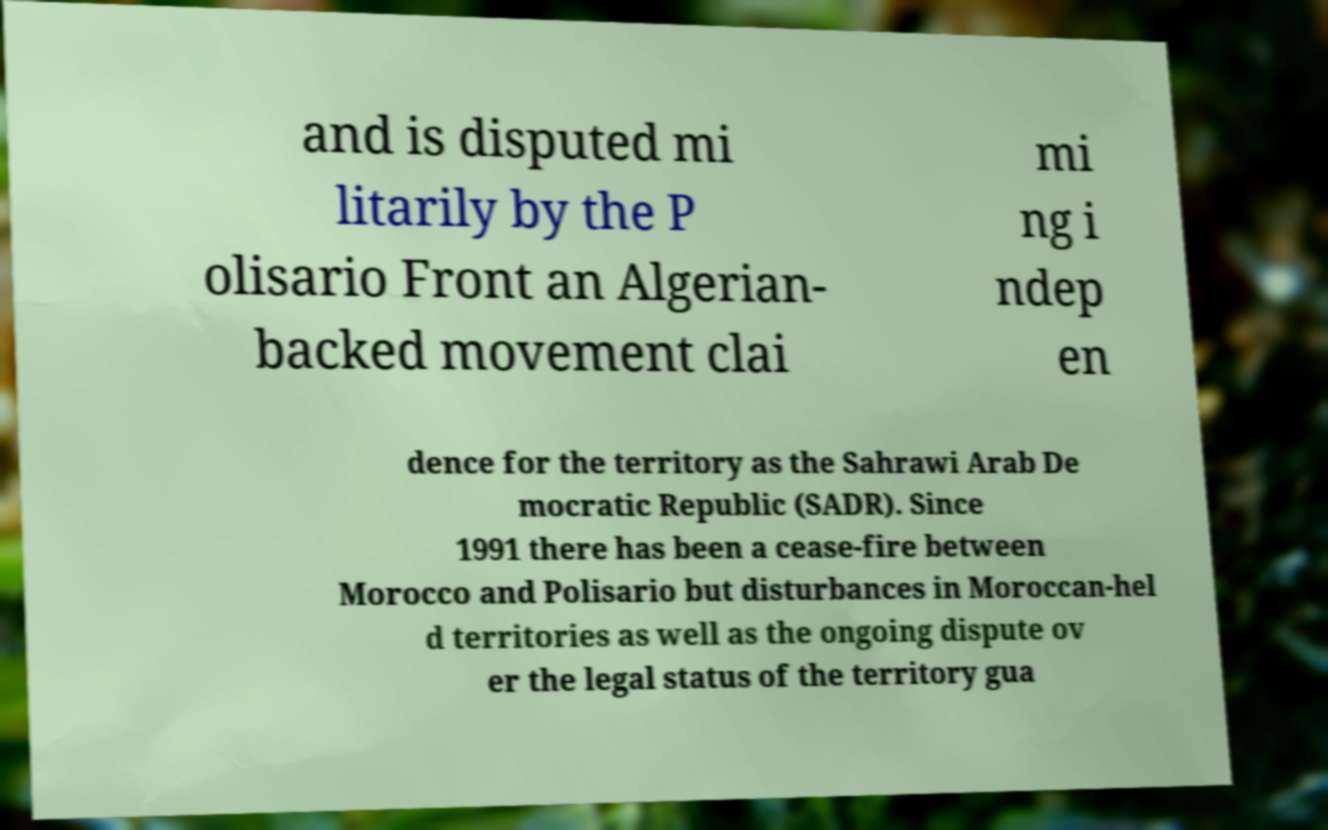Can you accurately transcribe the text from the provided image for me? and is disputed mi litarily by the P olisario Front an Algerian- backed movement clai mi ng i ndep en dence for the territory as the Sahrawi Arab De mocratic Republic (SADR). Since 1991 there has been a cease-fire between Morocco and Polisario but disturbances in Moroccan-hel d territories as well as the ongoing dispute ov er the legal status of the territory gua 